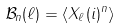<formula> <loc_0><loc_0><loc_500><loc_500>\mathcal { B } _ { n } ( \ell ) = \langle X _ { \ell } ( i ) ^ { n } \rangle</formula> 